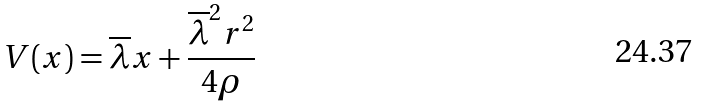<formula> <loc_0><loc_0><loc_500><loc_500>V ( x ) = \overline { \lambda } x + \frac { \overline { \lambda } ^ { 2 } r ^ { 2 } } { 4 \rho }</formula> 